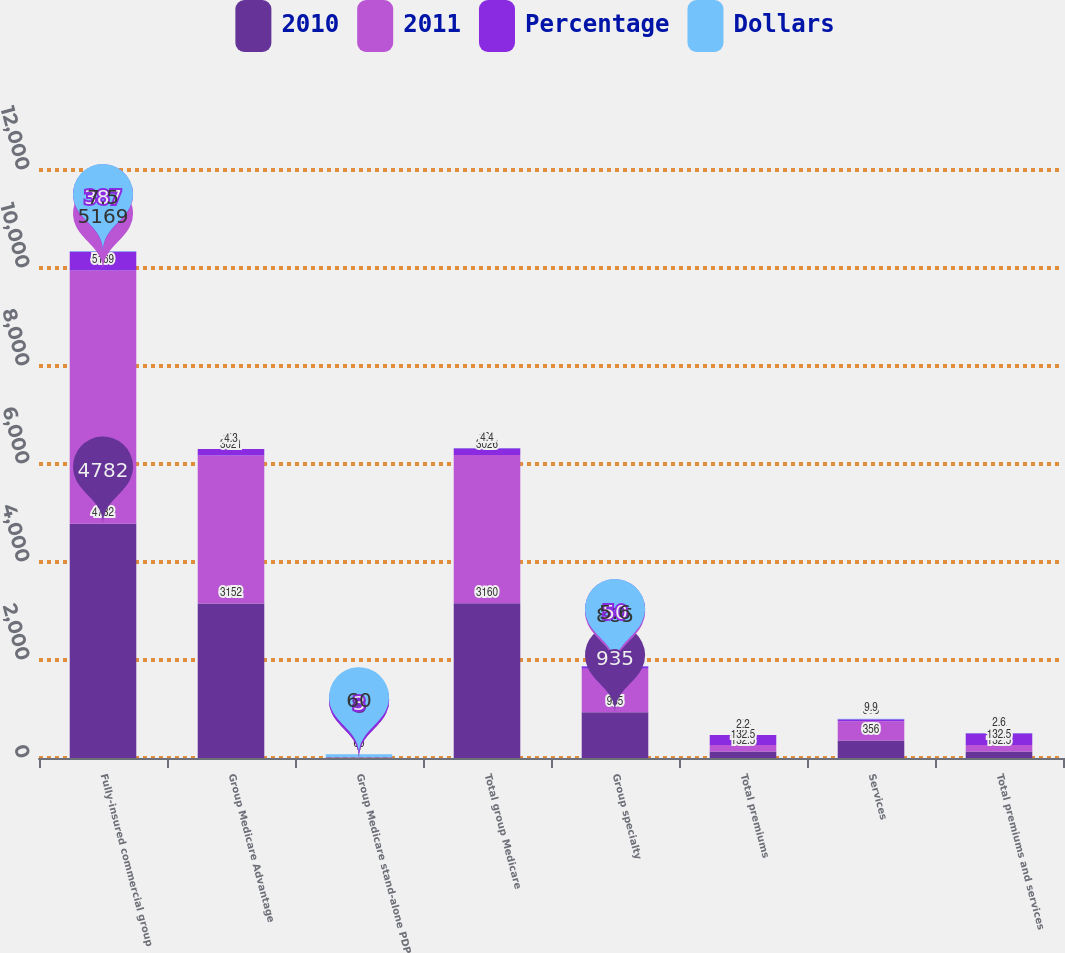<chart> <loc_0><loc_0><loc_500><loc_500><stacked_bar_chart><ecel><fcel>Fully-insured commercial group<fcel>Group Medicare Advantage<fcel>Group Medicare stand-alone PDP<fcel>Total group Medicare<fcel>Group specialty<fcel>Total premiums<fcel>Services<fcel>Total premiums and services<nl><fcel>2010<fcel>4782<fcel>3152<fcel>8<fcel>3160<fcel>935<fcel>132.5<fcel>356<fcel>132.5<nl><fcel>2011<fcel>5169<fcel>3021<fcel>5<fcel>3026<fcel>885<fcel>132.5<fcel>395<fcel>132.5<nl><fcel>Percentage<fcel>387<fcel>131<fcel>3<fcel>134<fcel>50<fcel>203<fcel>39<fcel>242<nl><fcel>Dollars<fcel>7.5<fcel>4.3<fcel>60<fcel>4.4<fcel>5.6<fcel>2.2<fcel>9.9<fcel>2.6<nl></chart> 